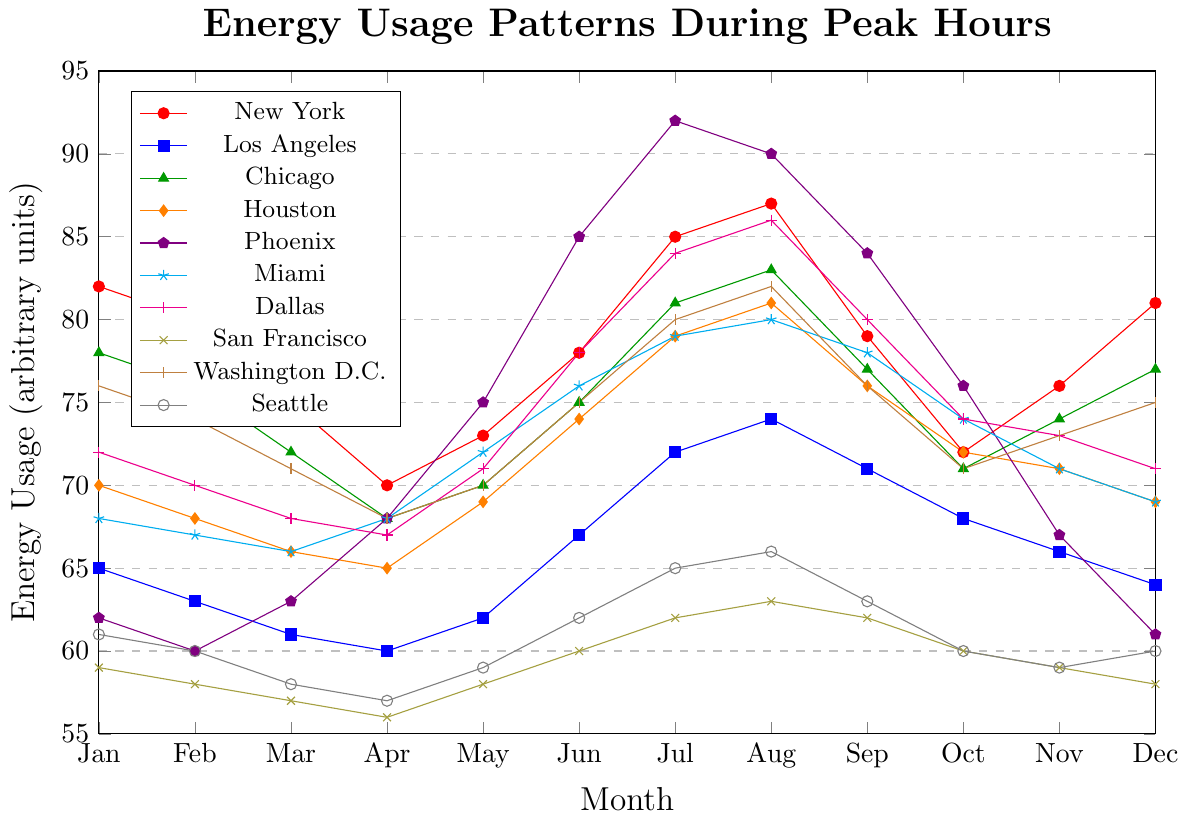Which city has the highest energy usage in August? To find the city with the highest energy usage in August, refer to the data points for each city in the month of August and identify the maximum value. Phoenix has the highest energy usage at 90 units.
Answer: Phoenix How does the energy usage in Seattle in July compare with that in February? Compare the energy usage values of Seattle in July and February from the figure. In July, Seattle's energy usage is 65, and in February, it is 60. Thus, the energy usage in July is higher than in February.
Answer: Higher What is the average energy usage in New York from April to June? Calculate the average of New York's energy usage for April (70), May (73), and June (78). The sum is 221, and the average is 221/3 = 73.67.
Answer: 73.67 Which two cities have nearly identical energy usage in December? Identify the data points for December and find the cities with similar values. Both Chicago and Washington D.C. have energy usage close to 75 units in December.
Answer: Chicago and Washington D.C In which month does Miami's energy usage peak, and what is the value? Analyze the figure to find the peak energy usage month for Miami. The maximum value is 80, which occurs in August.
Answer: August, 80 What trend do you observe in Phoenix's energy usage from January to July? Examine the figure for Phoenix from January to July. The trend shows a consistent increase starting from 62 in January and peaking at 92 in July.
Answer: Increasing trend Compare the energy usage in San Francisco and Washington D.C. in October Refer to the values for October for both cities. San Francisco has an energy usage of 60 units, while Washington D.C. has 71 units. Washington D.C. has a higher energy usage than San Francisco in October.
Answer: Washington D.C. is higher Between which months does Houston's energy usage increase the most? Analyze the monthly data for Houston to find the months with the steepest rise in energy usage. The most significant increase is between May (69) and June (74), totaling a 5-unit rise.
Answer: Between May and June Are there any months where the energy usage trend for Dallas and New York move in opposite directions? Compare the monthly trends for Dallas and New York. In April, New York’s energy usage drops from March to April, while Dallas’s usage remains the same. Therefore, no months show opposite trends within the dataset.
Answer: No What is the median energy usage value for Chicago throughout the year? List Chicago's monthly energy usage values (78, 76, 72, 68, 70, 75, 81, 83, 77, 71, 74, 77) and find the median by sorting them: (68, 70, 71, 72, 74, 75, 76, 77, 77, 78, 81, 83). The median values are 75 and 76, so the median is (75+76)/2 = 75.5.
Answer: 75.5 